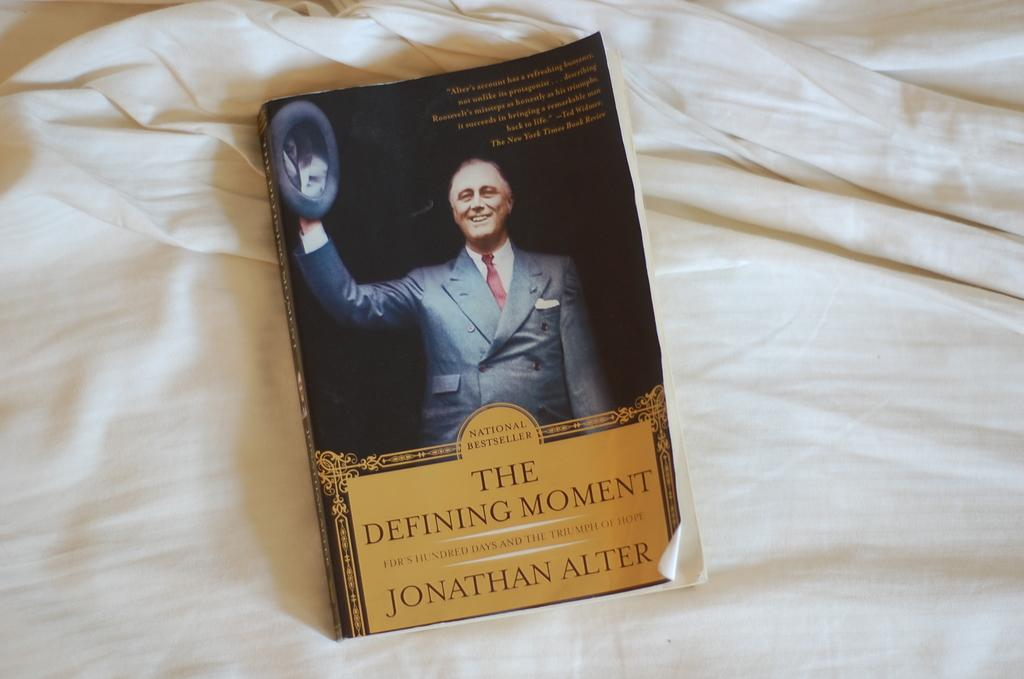Provide a one-sentence caption for the provided image. A book titled The Defining Moment sits on a bedsheet. 